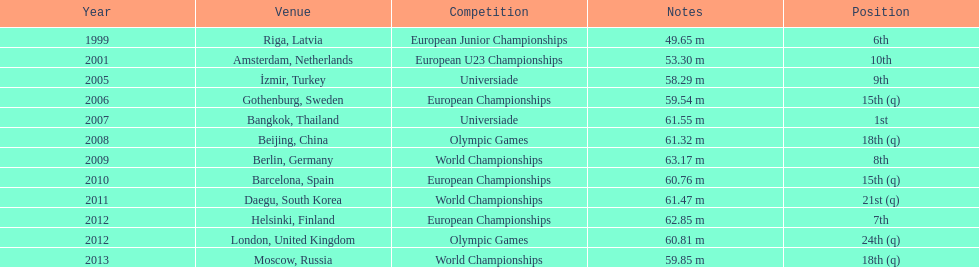What was mayer's best result: i.e his longest throw? 63.17 m. 